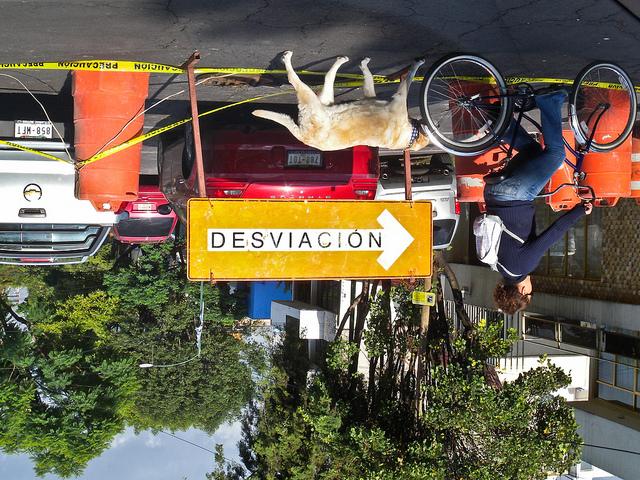Do the trees have leaves?
Keep it brief. Yes. Is the pic upside down?
Short answer required. Yes. What color is the sign?
Concise answer only. Yellow. 